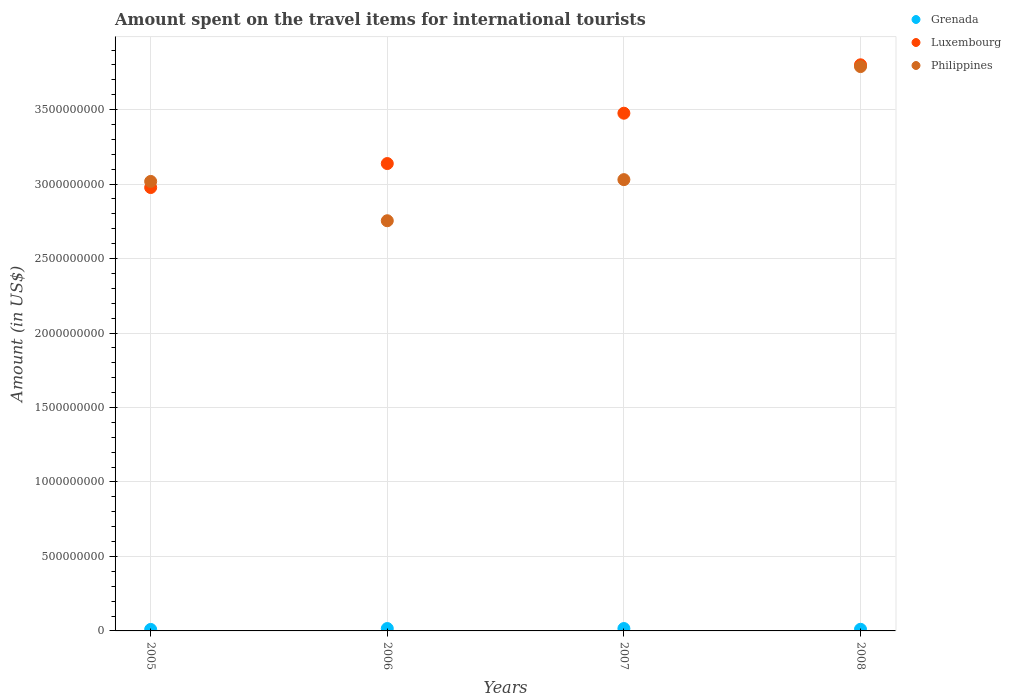How many different coloured dotlines are there?
Your answer should be compact. 3. Is the number of dotlines equal to the number of legend labels?
Your answer should be very brief. Yes. What is the amount spent on the travel items for international tourists in Luxembourg in 2008?
Offer a very short reply. 3.80e+09. Across all years, what is the maximum amount spent on the travel items for international tourists in Philippines?
Your response must be concise. 3.79e+09. Across all years, what is the minimum amount spent on the travel items for international tourists in Luxembourg?
Ensure brevity in your answer.  2.98e+09. In which year was the amount spent on the travel items for international tourists in Philippines minimum?
Give a very brief answer. 2006. What is the total amount spent on the travel items for international tourists in Luxembourg in the graph?
Your answer should be compact. 1.34e+1. What is the difference between the amount spent on the travel items for international tourists in Luxembourg in 2007 and that in 2008?
Provide a short and direct response. -3.25e+08. What is the difference between the amount spent on the travel items for international tourists in Luxembourg in 2007 and the amount spent on the travel items for international tourists in Grenada in 2008?
Offer a very short reply. 3.46e+09. What is the average amount spent on the travel items for international tourists in Grenada per year?
Give a very brief answer. 1.32e+07. In the year 2007, what is the difference between the amount spent on the travel items for international tourists in Grenada and amount spent on the travel items for international tourists in Philippines?
Provide a succinct answer. -3.01e+09. In how many years, is the amount spent on the travel items for international tourists in Philippines greater than 800000000 US$?
Your answer should be compact. 4. What is the ratio of the amount spent on the travel items for international tourists in Luxembourg in 2005 to that in 2008?
Make the answer very short. 0.78. What is the difference between the highest and the second highest amount spent on the travel items for international tourists in Luxembourg?
Your answer should be very brief. 3.25e+08. What is the difference between the highest and the lowest amount spent on the travel items for international tourists in Luxembourg?
Your answer should be compact. 8.24e+08. Is the amount spent on the travel items for international tourists in Luxembourg strictly greater than the amount spent on the travel items for international tourists in Grenada over the years?
Provide a succinct answer. Yes. How many years are there in the graph?
Provide a short and direct response. 4. What is the difference between two consecutive major ticks on the Y-axis?
Ensure brevity in your answer.  5.00e+08. Are the values on the major ticks of Y-axis written in scientific E-notation?
Make the answer very short. No. Does the graph contain grids?
Your response must be concise. Yes. Where does the legend appear in the graph?
Your answer should be very brief. Top right. How many legend labels are there?
Keep it short and to the point. 3. How are the legend labels stacked?
Ensure brevity in your answer.  Vertical. What is the title of the graph?
Provide a succinct answer. Amount spent on the travel items for international tourists. What is the label or title of the Y-axis?
Provide a short and direct response. Amount (in US$). What is the Amount (in US$) of Grenada in 2005?
Your answer should be very brief. 1.00e+07. What is the Amount (in US$) of Luxembourg in 2005?
Provide a succinct answer. 2.98e+09. What is the Amount (in US$) in Philippines in 2005?
Keep it short and to the point. 3.02e+09. What is the Amount (in US$) of Grenada in 2006?
Keep it short and to the point. 1.60e+07. What is the Amount (in US$) in Luxembourg in 2006?
Your response must be concise. 3.14e+09. What is the Amount (in US$) of Philippines in 2006?
Keep it short and to the point. 2.75e+09. What is the Amount (in US$) of Grenada in 2007?
Provide a succinct answer. 1.60e+07. What is the Amount (in US$) in Luxembourg in 2007?
Keep it short and to the point. 3.48e+09. What is the Amount (in US$) in Philippines in 2007?
Your response must be concise. 3.03e+09. What is the Amount (in US$) in Grenada in 2008?
Your answer should be compact. 1.10e+07. What is the Amount (in US$) of Luxembourg in 2008?
Offer a very short reply. 3.80e+09. What is the Amount (in US$) of Philippines in 2008?
Offer a very short reply. 3.79e+09. Across all years, what is the maximum Amount (in US$) in Grenada?
Your answer should be compact. 1.60e+07. Across all years, what is the maximum Amount (in US$) in Luxembourg?
Your response must be concise. 3.80e+09. Across all years, what is the maximum Amount (in US$) in Philippines?
Offer a very short reply. 3.79e+09. Across all years, what is the minimum Amount (in US$) in Grenada?
Your response must be concise. 1.00e+07. Across all years, what is the minimum Amount (in US$) of Luxembourg?
Your answer should be very brief. 2.98e+09. Across all years, what is the minimum Amount (in US$) in Philippines?
Give a very brief answer. 2.75e+09. What is the total Amount (in US$) of Grenada in the graph?
Your answer should be very brief. 5.30e+07. What is the total Amount (in US$) of Luxembourg in the graph?
Make the answer very short. 1.34e+1. What is the total Amount (in US$) in Philippines in the graph?
Make the answer very short. 1.26e+1. What is the difference between the Amount (in US$) in Grenada in 2005 and that in 2006?
Your answer should be very brief. -6.00e+06. What is the difference between the Amount (in US$) of Luxembourg in 2005 and that in 2006?
Offer a very short reply. -1.61e+08. What is the difference between the Amount (in US$) of Philippines in 2005 and that in 2006?
Offer a very short reply. 2.64e+08. What is the difference between the Amount (in US$) of Grenada in 2005 and that in 2007?
Give a very brief answer. -6.00e+06. What is the difference between the Amount (in US$) of Luxembourg in 2005 and that in 2007?
Make the answer very short. -4.99e+08. What is the difference between the Amount (in US$) of Philippines in 2005 and that in 2007?
Give a very brief answer. -1.20e+07. What is the difference between the Amount (in US$) in Luxembourg in 2005 and that in 2008?
Offer a very short reply. -8.24e+08. What is the difference between the Amount (in US$) in Philippines in 2005 and that in 2008?
Your answer should be very brief. -7.71e+08. What is the difference between the Amount (in US$) in Luxembourg in 2006 and that in 2007?
Keep it short and to the point. -3.38e+08. What is the difference between the Amount (in US$) in Philippines in 2006 and that in 2007?
Make the answer very short. -2.76e+08. What is the difference between the Amount (in US$) of Grenada in 2006 and that in 2008?
Offer a terse response. 5.00e+06. What is the difference between the Amount (in US$) in Luxembourg in 2006 and that in 2008?
Provide a succinct answer. -6.63e+08. What is the difference between the Amount (in US$) of Philippines in 2006 and that in 2008?
Make the answer very short. -1.04e+09. What is the difference between the Amount (in US$) of Luxembourg in 2007 and that in 2008?
Ensure brevity in your answer.  -3.25e+08. What is the difference between the Amount (in US$) of Philippines in 2007 and that in 2008?
Provide a succinct answer. -7.59e+08. What is the difference between the Amount (in US$) in Grenada in 2005 and the Amount (in US$) in Luxembourg in 2006?
Your answer should be compact. -3.13e+09. What is the difference between the Amount (in US$) of Grenada in 2005 and the Amount (in US$) of Philippines in 2006?
Offer a very short reply. -2.74e+09. What is the difference between the Amount (in US$) of Luxembourg in 2005 and the Amount (in US$) of Philippines in 2006?
Keep it short and to the point. 2.23e+08. What is the difference between the Amount (in US$) of Grenada in 2005 and the Amount (in US$) of Luxembourg in 2007?
Keep it short and to the point. -3.47e+09. What is the difference between the Amount (in US$) of Grenada in 2005 and the Amount (in US$) of Philippines in 2007?
Provide a succinct answer. -3.02e+09. What is the difference between the Amount (in US$) of Luxembourg in 2005 and the Amount (in US$) of Philippines in 2007?
Your answer should be very brief. -5.30e+07. What is the difference between the Amount (in US$) in Grenada in 2005 and the Amount (in US$) in Luxembourg in 2008?
Your answer should be very brief. -3.79e+09. What is the difference between the Amount (in US$) of Grenada in 2005 and the Amount (in US$) of Philippines in 2008?
Keep it short and to the point. -3.78e+09. What is the difference between the Amount (in US$) in Luxembourg in 2005 and the Amount (in US$) in Philippines in 2008?
Offer a terse response. -8.12e+08. What is the difference between the Amount (in US$) in Grenada in 2006 and the Amount (in US$) in Luxembourg in 2007?
Provide a short and direct response. -3.46e+09. What is the difference between the Amount (in US$) in Grenada in 2006 and the Amount (in US$) in Philippines in 2007?
Give a very brief answer. -3.01e+09. What is the difference between the Amount (in US$) of Luxembourg in 2006 and the Amount (in US$) of Philippines in 2007?
Offer a very short reply. 1.08e+08. What is the difference between the Amount (in US$) in Grenada in 2006 and the Amount (in US$) in Luxembourg in 2008?
Your answer should be compact. -3.78e+09. What is the difference between the Amount (in US$) in Grenada in 2006 and the Amount (in US$) in Philippines in 2008?
Offer a terse response. -3.77e+09. What is the difference between the Amount (in US$) in Luxembourg in 2006 and the Amount (in US$) in Philippines in 2008?
Your answer should be compact. -6.51e+08. What is the difference between the Amount (in US$) of Grenada in 2007 and the Amount (in US$) of Luxembourg in 2008?
Your answer should be very brief. -3.78e+09. What is the difference between the Amount (in US$) in Grenada in 2007 and the Amount (in US$) in Philippines in 2008?
Offer a very short reply. -3.77e+09. What is the difference between the Amount (in US$) in Luxembourg in 2007 and the Amount (in US$) in Philippines in 2008?
Your answer should be compact. -3.13e+08. What is the average Amount (in US$) of Grenada per year?
Make the answer very short. 1.32e+07. What is the average Amount (in US$) in Luxembourg per year?
Offer a very short reply. 3.35e+09. What is the average Amount (in US$) in Philippines per year?
Offer a very short reply. 3.15e+09. In the year 2005, what is the difference between the Amount (in US$) of Grenada and Amount (in US$) of Luxembourg?
Provide a succinct answer. -2.97e+09. In the year 2005, what is the difference between the Amount (in US$) in Grenada and Amount (in US$) in Philippines?
Your answer should be compact. -3.01e+09. In the year 2005, what is the difference between the Amount (in US$) of Luxembourg and Amount (in US$) of Philippines?
Keep it short and to the point. -4.10e+07. In the year 2006, what is the difference between the Amount (in US$) of Grenada and Amount (in US$) of Luxembourg?
Ensure brevity in your answer.  -3.12e+09. In the year 2006, what is the difference between the Amount (in US$) of Grenada and Amount (in US$) of Philippines?
Ensure brevity in your answer.  -2.74e+09. In the year 2006, what is the difference between the Amount (in US$) in Luxembourg and Amount (in US$) in Philippines?
Provide a succinct answer. 3.84e+08. In the year 2007, what is the difference between the Amount (in US$) in Grenada and Amount (in US$) in Luxembourg?
Offer a very short reply. -3.46e+09. In the year 2007, what is the difference between the Amount (in US$) of Grenada and Amount (in US$) of Philippines?
Offer a terse response. -3.01e+09. In the year 2007, what is the difference between the Amount (in US$) in Luxembourg and Amount (in US$) in Philippines?
Provide a short and direct response. 4.46e+08. In the year 2008, what is the difference between the Amount (in US$) in Grenada and Amount (in US$) in Luxembourg?
Give a very brief answer. -3.79e+09. In the year 2008, what is the difference between the Amount (in US$) of Grenada and Amount (in US$) of Philippines?
Your answer should be very brief. -3.78e+09. What is the ratio of the Amount (in US$) of Luxembourg in 2005 to that in 2006?
Keep it short and to the point. 0.95. What is the ratio of the Amount (in US$) in Philippines in 2005 to that in 2006?
Provide a short and direct response. 1.1. What is the ratio of the Amount (in US$) of Luxembourg in 2005 to that in 2007?
Give a very brief answer. 0.86. What is the ratio of the Amount (in US$) of Philippines in 2005 to that in 2007?
Provide a short and direct response. 1. What is the ratio of the Amount (in US$) of Grenada in 2005 to that in 2008?
Keep it short and to the point. 0.91. What is the ratio of the Amount (in US$) in Luxembourg in 2005 to that in 2008?
Offer a very short reply. 0.78. What is the ratio of the Amount (in US$) in Philippines in 2005 to that in 2008?
Provide a short and direct response. 0.8. What is the ratio of the Amount (in US$) of Luxembourg in 2006 to that in 2007?
Your answer should be very brief. 0.9. What is the ratio of the Amount (in US$) of Philippines in 2006 to that in 2007?
Keep it short and to the point. 0.91. What is the ratio of the Amount (in US$) in Grenada in 2006 to that in 2008?
Give a very brief answer. 1.45. What is the ratio of the Amount (in US$) of Luxembourg in 2006 to that in 2008?
Provide a succinct answer. 0.83. What is the ratio of the Amount (in US$) of Philippines in 2006 to that in 2008?
Offer a terse response. 0.73. What is the ratio of the Amount (in US$) of Grenada in 2007 to that in 2008?
Ensure brevity in your answer.  1.45. What is the ratio of the Amount (in US$) in Luxembourg in 2007 to that in 2008?
Make the answer very short. 0.91. What is the ratio of the Amount (in US$) of Philippines in 2007 to that in 2008?
Provide a short and direct response. 0.8. What is the difference between the highest and the second highest Amount (in US$) of Grenada?
Your answer should be very brief. 0. What is the difference between the highest and the second highest Amount (in US$) in Luxembourg?
Make the answer very short. 3.25e+08. What is the difference between the highest and the second highest Amount (in US$) in Philippines?
Your response must be concise. 7.59e+08. What is the difference between the highest and the lowest Amount (in US$) in Luxembourg?
Make the answer very short. 8.24e+08. What is the difference between the highest and the lowest Amount (in US$) in Philippines?
Your answer should be very brief. 1.04e+09. 